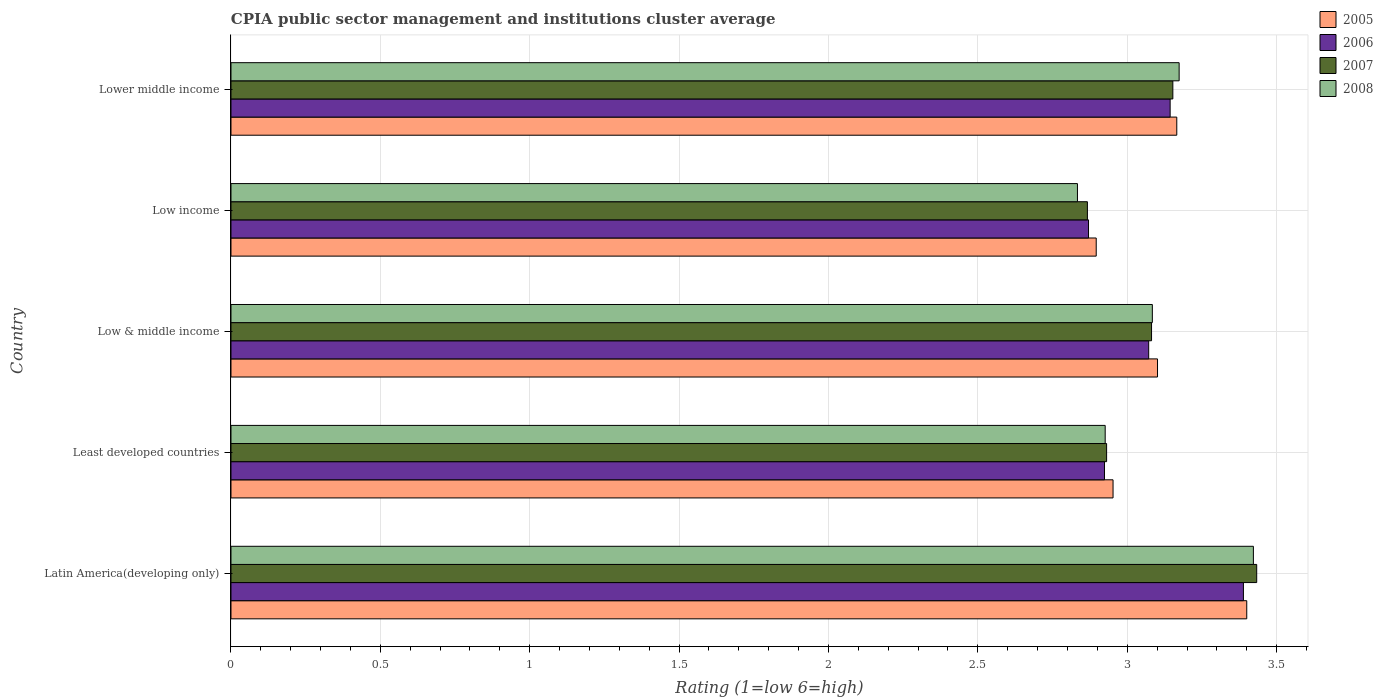How many different coloured bars are there?
Your answer should be very brief. 4. Are the number of bars per tick equal to the number of legend labels?
Provide a short and direct response. Yes. Are the number of bars on each tick of the Y-axis equal?
Offer a terse response. Yes. How many bars are there on the 5th tick from the top?
Keep it short and to the point. 4. What is the CPIA rating in 2007 in Latin America(developing only)?
Your response must be concise. 3.43. Across all countries, what is the maximum CPIA rating in 2008?
Your answer should be very brief. 3.42. Across all countries, what is the minimum CPIA rating in 2006?
Keep it short and to the point. 2.87. In which country was the CPIA rating in 2006 maximum?
Offer a terse response. Latin America(developing only). In which country was the CPIA rating in 2006 minimum?
Keep it short and to the point. Low income. What is the total CPIA rating in 2005 in the graph?
Your answer should be very brief. 15.52. What is the difference between the CPIA rating in 2007 in Least developed countries and that in Low income?
Make the answer very short. 0.06. What is the difference between the CPIA rating in 2005 in Latin America(developing only) and the CPIA rating in 2008 in Low & middle income?
Offer a terse response. 0.32. What is the average CPIA rating in 2006 per country?
Offer a very short reply. 3.08. What is the difference between the CPIA rating in 2007 and CPIA rating in 2008 in Latin America(developing only)?
Your answer should be compact. 0.01. What is the ratio of the CPIA rating in 2007 in Latin America(developing only) to that in Low & middle income?
Provide a short and direct response. 1.11. Is the CPIA rating in 2006 in Latin America(developing only) less than that in Low & middle income?
Your response must be concise. No. What is the difference between the highest and the second highest CPIA rating in 2007?
Your response must be concise. 0.28. What is the difference between the highest and the lowest CPIA rating in 2008?
Ensure brevity in your answer.  0.59. In how many countries, is the CPIA rating in 2008 greater than the average CPIA rating in 2008 taken over all countries?
Your answer should be very brief. 2. Is the sum of the CPIA rating in 2005 in Low & middle income and Lower middle income greater than the maximum CPIA rating in 2007 across all countries?
Your answer should be very brief. Yes. Is it the case that in every country, the sum of the CPIA rating in 2006 and CPIA rating in 2007 is greater than the sum of CPIA rating in 2005 and CPIA rating in 2008?
Ensure brevity in your answer.  No. Are all the bars in the graph horizontal?
Ensure brevity in your answer.  Yes. How many countries are there in the graph?
Make the answer very short. 5. What is the difference between two consecutive major ticks on the X-axis?
Give a very brief answer. 0.5. Are the values on the major ticks of X-axis written in scientific E-notation?
Ensure brevity in your answer.  No. Does the graph contain grids?
Your answer should be very brief. Yes. Where does the legend appear in the graph?
Offer a terse response. Top right. How are the legend labels stacked?
Offer a terse response. Vertical. What is the title of the graph?
Provide a short and direct response. CPIA public sector management and institutions cluster average. What is the label or title of the X-axis?
Provide a succinct answer. Rating (1=low 6=high). What is the label or title of the Y-axis?
Your answer should be very brief. Country. What is the Rating (1=low 6=high) of 2005 in Latin America(developing only)?
Give a very brief answer. 3.4. What is the Rating (1=low 6=high) of 2006 in Latin America(developing only)?
Your answer should be very brief. 3.39. What is the Rating (1=low 6=high) of 2007 in Latin America(developing only)?
Offer a terse response. 3.43. What is the Rating (1=low 6=high) of 2008 in Latin America(developing only)?
Give a very brief answer. 3.42. What is the Rating (1=low 6=high) in 2005 in Least developed countries?
Ensure brevity in your answer.  2.95. What is the Rating (1=low 6=high) in 2006 in Least developed countries?
Keep it short and to the point. 2.92. What is the Rating (1=low 6=high) of 2007 in Least developed countries?
Keep it short and to the point. 2.93. What is the Rating (1=low 6=high) of 2008 in Least developed countries?
Make the answer very short. 2.93. What is the Rating (1=low 6=high) of 2005 in Low & middle income?
Your response must be concise. 3.1. What is the Rating (1=low 6=high) in 2006 in Low & middle income?
Your response must be concise. 3.07. What is the Rating (1=low 6=high) of 2007 in Low & middle income?
Provide a succinct answer. 3.08. What is the Rating (1=low 6=high) of 2008 in Low & middle income?
Your response must be concise. 3.08. What is the Rating (1=low 6=high) of 2005 in Low income?
Make the answer very short. 2.9. What is the Rating (1=low 6=high) of 2006 in Low income?
Provide a succinct answer. 2.87. What is the Rating (1=low 6=high) of 2007 in Low income?
Keep it short and to the point. 2.87. What is the Rating (1=low 6=high) in 2008 in Low income?
Your answer should be very brief. 2.83. What is the Rating (1=low 6=high) in 2005 in Lower middle income?
Offer a very short reply. 3.17. What is the Rating (1=low 6=high) of 2006 in Lower middle income?
Offer a very short reply. 3.14. What is the Rating (1=low 6=high) in 2007 in Lower middle income?
Your response must be concise. 3.15. What is the Rating (1=low 6=high) in 2008 in Lower middle income?
Your answer should be compact. 3.17. Across all countries, what is the maximum Rating (1=low 6=high) of 2006?
Give a very brief answer. 3.39. Across all countries, what is the maximum Rating (1=low 6=high) of 2007?
Provide a succinct answer. 3.43. Across all countries, what is the maximum Rating (1=low 6=high) of 2008?
Offer a very short reply. 3.42. Across all countries, what is the minimum Rating (1=low 6=high) in 2005?
Your answer should be compact. 2.9. Across all countries, what is the minimum Rating (1=low 6=high) in 2006?
Your response must be concise. 2.87. Across all countries, what is the minimum Rating (1=low 6=high) of 2007?
Ensure brevity in your answer.  2.87. Across all countries, what is the minimum Rating (1=low 6=high) in 2008?
Ensure brevity in your answer.  2.83. What is the total Rating (1=low 6=high) in 2005 in the graph?
Make the answer very short. 15.52. What is the total Rating (1=low 6=high) of 2006 in the graph?
Offer a terse response. 15.4. What is the total Rating (1=low 6=high) of 2007 in the graph?
Provide a succinct answer. 15.46. What is the total Rating (1=low 6=high) of 2008 in the graph?
Ensure brevity in your answer.  15.44. What is the difference between the Rating (1=low 6=high) of 2005 in Latin America(developing only) and that in Least developed countries?
Make the answer very short. 0.45. What is the difference between the Rating (1=low 6=high) in 2006 in Latin America(developing only) and that in Least developed countries?
Your response must be concise. 0.47. What is the difference between the Rating (1=low 6=high) in 2007 in Latin America(developing only) and that in Least developed countries?
Provide a short and direct response. 0.5. What is the difference between the Rating (1=low 6=high) in 2008 in Latin America(developing only) and that in Least developed countries?
Offer a very short reply. 0.5. What is the difference between the Rating (1=low 6=high) of 2005 in Latin America(developing only) and that in Low & middle income?
Make the answer very short. 0.3. What is the difference between the Rating (1=low 6=high) of 2006 in Latin America(developing only) and that in Low & middle income?
Provide a short and direct response. 0.32. What is the difference between the Rating (1=low 6=high) of 2007 in Latin America(developing only) and that in Low & middle income?
Offer a terse response. 0.35. What is the difference between the Rating (1=low 6=high) in 2008 in Latin America(developing only) and that in Low & middle income?
Ensure brevity in your answer.  0.34. What is the difference between the Rating (1=low 6=high) in 2005 in Latin America(developing only) and that in Low income?
Your answer should be very brief. 0.5. What is the difference between the Rating (1=low 6=high) in 2006 in Latin America(developing only) and that in Low income?
Your response must be concise. 0.52. What is the difference between the Rating (1=low 6=high) of 2007 in Latin America(developing only) and that in Low income?
Your response must be concise. 0.57. What is the difference between the Rating (1=low 6=high) of 2008 in Latin America(developing only) and that in Low income?
Keep it short and to the point. 0.59. What is the difference between the Rating (1=low 6=high) of 2005 in Latin America(developing only) and that in Lower middle income?
Offer a terse response. 0.23. What is the difference between the Rating (1=low 6=high) of 2006 in Latin America(developing only) and that in Lower middle income?
Provide a succinct answer. 0.25. What is the difference between the Rating (1=low 6=high) in 2007 in Latin America(developing only) and that in Lower middle income?
Your answer should be very brief. 0.28. What is the difference between the Rating (1=low 6=high) in 2008 in Latin America(developing only) and that in Lower middle income?
Offer a terse response. 0.25. What is the difference between the Rating (1=low 6=high) in 2005 in Least developed countries and that in Low & middle income?
Keep it short and to the point. -0.15. What is the difference between the Rating (1=low 6=high) in 2006 in Least developed countries and that in Low & middle income?
Your answer should be very brief. -0.15. What is the difference between the Rating (1=low 6=high) in 2007 in Least developed countries and that in Low & middle income?
Your answer should be compact. -0.15. What is the difference between the Rating (1=low 6=high) of 2008 in Least developed countries and that in Low & middle income?
Keep it short and to the point. -0.16. What is the difference between the Rating (1=low 6=high) in 2005 in Least developed countries and that in Low income?
Ensure brevity in your answer.  0.06. What is the difference between the Rating (1=low 6=high) in 2006 in Least developed countries and that in Low income?
Ensure brevity in your answer.  0.05. What is the difference between the Rating (1=low 6=high) of 2007 in Least developed countries and that in Low income?
Give a very brief answer. 0.06. What is the difference between the Rating (1=low 6=high) of 2008 in Least developed countries and that in Low income?
Offer a very short reply. 0.09. What is the difference between the Rating (1=low 6=high) in 2005 in Least developed countries and that in Lower middle income?
Offer a very short reply. -0.21. What is the difference between the Rating (1=low 6=high) in 2006 in Least developed countries and that in Lower middle income?
Make the answer very short. -0.22. What is the difference between the Rating (1=low 6=high) of 2007 in Least developed countries and that in Lower middle income?
Your answer should be compact. -0.22. What is the difference between the Rating (1=low 6=high) of 2008 in Least developed countries and that in Lower middle income?
Provide a short and direct response. -0.25. What is the difference between the Rating (1=low 6=high) in 2005 in Low & middle income and that in Low income?
Your response must be concise. 0.21. What is the difference between the Rating (1=low 6=high) of 2006 in Low & middle income and that in Low income?
Your answer should be very brief. 0.2. What is the difference between the Rating (1=low 6=high) in 2007 in Low & middle income and that in Low income?
Keep it short and to the point. 0.21. What is the difference between the Rating (1=low 6=high) of 2008 in Low & middle income and that in Low income?
Your answer should be very brief. 0.25. What is the difference between the Rating (1=low 6=high) of 2005 in Low & middle income and that in Lower middle income?
Make the answer very short. -0.06. What is the difference between the Rating (1=low 6=high) of 2006 in Low & middle income and that in Lower middle income?
Keep it short and to the point. -0.07. What is the difference between the Rating (1=low 6=high) in 2007 in Low & middle income and that in Lower middle income?
Make the answer very short. -0.07. What is the difference between the Rating (1=low 6=high) of 2008 in Low & middle income and that in Lower middle income?
Give a very brief answer. -0.09. What is the difference between the Rating (1=low 6=high) of 2005 in Low income and that in Lower middle income?
Offer a very short reply. -0.27. What is the difference between the Rating (1=low 6=high) in 2006 in Low income and that in Lower middle income?
Offer a very short reply. -0.27. What is the difference between the Rating (1=low 6=high) of 2007 in Low income and that in Lower middle income?
Your response must be concise. -0.29. What is the difference between the Rating (1=low 6=high) of 2008 in Low income and that in Lower middle income?
Your response must be concise. -0.34. What is the difference between the Rating (1=low 6=high) of 2005 in Latin America(developing only) and the Rating (1=low 6=high) of 2006 in Least developed countries?
Offer a terse response. 0.48. What is the difference between the Rating (1=low 6=high) of 2005 in Latin America(developing only) and the Rating (1=low 6=high) of 2007 in Least developed countries?
Give a very brief answer. 0.47. What is the difference between the Rating (1=low 6=high) in 2005 in Latin America(developing only) and the Rating (1=low 6=high) in 2008 in Least developed countries?
Give a very brief answer. 0.47. What is the difference between the Rating (1=low 6=high) of 2006 in Latin America(developing only) and the Rating (1=low 6=high) of 2007 in Least developed countries?
Your answer should be very brief. 0.46. What is the difference between the Rating (1=low 6=high) of 2006 in Latin America(developing only) and the Rating (1=low 6=high) of 2008 in Least developed countries?
Make the answer very short. 0.46. What is the difference between the Rating (1=low 6=high) of 2007 in Latin America(developing only) and the Rating (1=low 6=high) of 2008 in Least developed countries?
Your answer should be compact. 0.51. What is the difference between the Rating (1=low 6=high) in 2005 in Latin America(developing only) and the Rating (1=low 6=high) in 2006 in Low & middle income?
Provide a succinct answer. 0.33. What is the difference between the Rating (1=low 6=high) of 2005 in Latin America(developing only) and the Rating (1=low 6=high) of 2007 in Low & middle income?
Your response must be concise. 0.32. What is the difference between the Rating (1=low 6=high) of 2005 in Latin America(developing only) and the Rating (1=low 6=high) of 2008 in Low & middle income?
Provide a short and direct response. 0.32. What is the difference between the Rating (1=low 6=high) of 2006 in Latin America(developing only) and the Rating (1=low 6=high) of 2007 in Low & middle income?
Offer a terse response. 0.31. What is the difference between the Rating (1=low 6=high) in 2006 in Latin America(developing only) and the Rating (1=low 6=high) in 2008 in Low & middle income?
Provide a short and direct response. 0.3. What is the difference between the Rating (1=low 6=high) in 2007 in Latin America(developing only) and the Rating (1=low 6=high) in 2008 in Low & middle income?
Your response must be concise. 0.35. What is the difference between the Rating (1=low 6=high) of 2005 in Latin America(developing only) and the Rating (1=low 6=high) of 2006 in Low income?
Offer a very short reply. 0.53. What is the difference between the Rating (1=low 6=high) of 2005 in Latin America(developing only) and the Rating (1=low 6=high) of 2007 in Low income?
Make the answer very short. 0.53. What is the difference between the Rating (1=low 6=high) of 2005 in Latin America(developing only) and the Rating (1=low 6=high) of 2008 in Low income?
Give a very brief answer. 0.57. What is the difference between the Rating (1=low 6=high) of 2006 in Latin America(developing only) and the Rating (1=low 6=high) of 2007 in Low income?
Provide a succinct answer. 0.52. What is the difference between the Rating (1=low 6=high) of 2006 in Latin America(developing only) and the Rating (1=low 6=high) of 2008 in Low income?
Give a very brief answer. 0.56. What is the difference between the Rating (1=low 6=high) of 2005 in Latin America(developing only) and the Rating (1=low 6=high) of 2006 in Lower middle income?
Your answer should be compact. 0.26. What is the difference between the Rating (1=low 6=high) of 2005 in Latin America(developing only) and the Rating (1=low 6=high) of 2007 in Lower middle income?
Give a very brief answer. 0.25. What is the difference between the Rating (1=low 6=high) of 2005 in Latin America(developing only) and the Rating (1=low 6=high) of 2008 in Lower middle income?
Keep it short and to the point. 0.23. What is the difference between the Rating (1=low 6=high) of 2006 in Latin America(developing only) and the Rating (1=low 6=high) of 2007 in Lower middle income?
Provide a short and direct response. 0.24. What is the difference between the Rating (1=low 6=high) in 2006 in Latin America(developing only) and the Rating (1=low 6=high) in 2008 in Lower middle income?
Offer a very short reply. 0.22. What is the difference between the Rating (1=low 6=high) of 2007 in Latin America(developing only) and the Rating (1=low 6=high) of 2008 in Lower middle income?
Your response must be concise. 0.26. What is the difference between the Rating (1=low 6=high) in 2005 in Least developed countries and the Rating (1=low 6=high) in 2006 in Low & middle income?
Make the answer very short. -0.12. What is the difference between the Rating (1=low 6=high) in 2005 in Least developed countries and the Rating (1=low 6=high) in 2007 in Low & middle income?
Make the answer very short. -0.13. What is the difference between the Rating (1=low 6=high) of 2005 in Least developed countries and the Rating (1=low 6=high) of 2008 in Low & middle income?
Provide a short and direct response. -0.13. What is the difference between the Rating (1=low 6=high) in 2006 in Least developed countries and the Rating (1=low 6=high) in 2007 in Low & middle income?
Provide a succinct answer. -0.16. What is the difference between the Rating (1=low 6=high) in 2006 in Least developed countries and the Rating (1=low 6=high) in 2008 in Low & middle income?
Offer a terse response. -0.16. What is the difference between the Rating (1=low 6=high) in 2007 in Least developed countries and the Rating (1=low 6=high) in 2008 in Low & middle income?
Offer a very short reply. -0.15. What is the difference between the Rating (1=low 6=high) of 2005 in Least developed countries and the Rating (1=low 6=high) of 2006 in Low income?
Provide a short and direct response. 0.08. What is the difference between the Rating (1=low 6=high) in 2005 in Least developed countries and the Rating (1=low 6=high) in 2007 in Low income?
Keep it short and to the point. 0.09. What is the difference between the Rating (1=low 6=high) in 2005 in Least developed countries and the Rating (1=low 6=high) in 2008 in Low income?
Offer a terse response. 0.12. What is the difference between the Rating (1=low 6=high) in 2006 in Least developed countries and the Rating (1=low 6=high) in 2007 in Low income?
Provide a short and direct response. 0.06. What is the difference between the Rating (1=low 6=high) of 2006 in Least developed countries and the Rating (1=low 6=high) of 2008 in Low income?
Your response must be concise. 0.09. What is the difference between the Rating (1=low 6=high) of 2007 in Least developed countries and the Rating (1=low 6=high) of 2008 in Low income?
Your response must be concise. 0.1. What is the difference between the Rating (1=low 6=high) of 2005 in Least developed countries and the Rating (1=low 6=high) of 2006 in Lower middle income?
Offer a terse response. -0.19. What is the difference between the Rating (1=low 6=high) in 2005 in Least developed countries and the Rating (1=low 6=high) in 2007 in Lower middle income?
Give a very brief answer. -0.2. What is the difference between the Rating (1=low 6=high) in 2005 in Least developed countries and the Rating (1=low 6=high) in 2008 in Lower middle income?
Your response must be concise. -0.22. What is the difference between the Rating (1=low 6=high) of 2006 in Least developed countries and the Rating (1=low 6=high) of 2007 in Lower middle income?
Your answer should be compact. -0.23. What is the difference between the Rating (1=low 6=high) in 2006 in Least developed countries and the Rating (1=low 6=high) in 2008 in Lower middle income?
Make the answer very short. -0.25. What is the difference between the Rating (1=low 6=high) of 2007 in Least developed countries and the Rating (1=low 6=high) of 2008 in Lower middle income?
Offer a terse response. -0.24. What is the difference between the Rating (1=low 6=high) in 2005 in Low & middle income and the Rating (1=low 6=high) in 2006 in Low income?
Provide a succinct answer. 0.23. What is the difference between the Rating (1=low 6=high) in 2005 in Low & middle income and the Rating (1=low 6=high) in 2007 in Low income?
Make the answer very short. 0.23. What is the difference between the Rating (1=low 6=high) of 2005 in Low & middle income and the Rating (1=low 6=high) of 2008 in Low income?
Your response must be concise. 0.27. What is the difference between the Rating (1=low 6=high) in 2006 in Low & middle income and the Rating (1=low 6=high) in 2007 in Low income?
Keep it short and to the point. 0.21. What is the difference between the Rating (1=low 6=high) of 2006 in Low & middle income and the Rating (1=low 6=high) of 2008 in Low income?
Offer a very short reply. 0.24. What is the difference between the Rating (1=low 6=high) of 2007 in Low & middle income and the Rating (1=low 6=high) of 2008 in Low income?
Ensure brevity in your answer.  0.25. What is the difference between the Rating (1=low 6=high) in 2005 in Low & middle income and the Rating (1=low 6=high) in 2006 in Lower middle income?
Your answer should be very brief. -0.04. What is the difference between the Rating (1=low 6=high) in 2005 in Low & middle income and the Rating (1=low 6=high) in 2007 in Lower middle income?
Your answer should be compact. -0.05. What is the difference between the Rating (1=low 6=high) in 2005 in Low & middle income and the Rating (1=low 6=high) in 2008 in Lower middle income?
Give a very brief answer. -0.07. What is the difference between the Rating (1=low 6=high) of 2006 in Low & middle income and the Rating (1=low 6=high) of 2007 in Lower middle income?
Your response must be concise. -0.08. What is the difference between the Rating (1=low 6=high) of 2006 in Low & middle income and the Rating (1=low 6=high) of 2008 in Lower middle income?
Provide a succinct answer. -0.1. What is the difference between the Rating (1=low 6=high) in 2007 in Low & middle income and the Rating (1=low 6=high) in 2008 in Lower middle income?
Offer a terse response. -0.09. What is the difference between the Rating (1=low 6=high) in 2005 in Low income and the Rating (1=low 6=high) in 2006 in Lower middle income?
Give a very brief answer. -0.25. What is the difference between the Rating (1=low 6=high) in 2005 in Low income and the Rating (1=low 6=high) in 2007 in Lower middle income?
Your answer should be very brief. -0.26. What is the difference between the Rating (1=low 6=high) in 2005 in Low income and the Rating (1=low 6=high) in 2008 in Lower middle income?
Offer a terse response. -0.28. What is the difference between the Rating (1=low 6=high) in 2006 in Low income and the Rating (1=low 6=high) in 2007 in Lower middle income?
Your answer should be compact. -0.28. What is the difference between the Rating (1=low 6=high) of 2006 in Low income and the Rating (1=low 6=high) of 2008 in Lower middle income?
Ensure brevity in your answer.  -0.3. What is the difference between the Rating (1=low 6=high) of 2007 in Low income and the Rating (1=low 6=high) of 2008 in Lower middle income?
Keep it short and to the point. -0.31. What is the average Rating (1=low 6=high) of 2005 per country?
Keep it short and to the point. 3.1. What is the average Rating (1=low 6=high) in 2006 per country?
Provide a short and direct response. 3.08. What is the average Rating (1=low 6=high) of 2007 per country?
Provide a short and direct response. 3.09. What is the average Rating (1=low 6=high) in 2008 per country?
Your answer should be very brief. 3.09. What is the difference between the Rating (1=low 6=high) of 2005 and Rating (1=low 6=high) of 2006 in Latin America(developing only)?
Your response must be concise. 0.01. What is the difference between the Rating (1=low 6=high) of 2005 and Rating (1=low 6=high) of 2007 in Latin America(developing only)?
Provide a short and direct response. -0.03. What is the difference between the Rating (1=low 6=high) in 2005 and Rating (1=low 6=high) in 2008 in Latin America(developing only)?
Your answer should be very brief. -0.02. What is the difference between the Rating (1=low 6=high) in 2006 and Rating (1=low 6=high) in 2007 in Latin America(developing only)?
Ensure brevity in your answer.  -0.04. What is the difference between the Rating (1=low 6=high) in 2006 and Rating (1=low 6=high) in 2008 in Latin America(developing only)?
Keep it short and to the point. -0.03. What is the difference between the Rating (1=low 6=high) of 2007 and Rating (1=low 6=high) of 2008 in Latin America(developing only)?
Provide a short and direct response. 0.01. What is the difference between the Rating (1=low 6=high) of 2005 and Rating (1=low 6=high) of 2006 in Least developed countries?
Make the answer very short. 0.03. What is the difference between the Rating (1=low 6=high) of 2005 and Rating (1=low 6=high) of 2007 in Least developed countries?
Offer a very short reply. 0.02. What is the difference between the Rating (1=low 6=high) of 2005 and Rating (1=low 6=high) of 2008 in Least developed countries?
Your answer should be compact. 0.03. What is the difference between the Rating (1=low 6=high) of 2006 and Rating (1=low 6=high) of 2007 in Least developed countries?
Give a very brief answer. -0.01. What is the difference between the Rating (1=low 6=high) in 2006 and Rating (1=low 6=high) in 2008 in Least developed countries?
Your response must be concise. -0. What is the difference between the Rating (1=low 6=high) of 2007 and Rating (1=low 6=high) of 2008 in Least developed countries?
Your answer should be very brief. 0. What is the difference between the Rating (1=low 6=high) in 2005 and Rating (1=low 6=high) in 2006 in Low & middle income?
Your answer should be very brief. 0.03. What is the difference between the Rating (1=low 6=high) of 2005 and Rating (1=low 6=high) of 2008 in Low & middle income?
Keep it short and to the point. 0.02. What is the difference between the Rating (1=low 6=high) in 2006 and Rating (1=low 6=high) in 2007 in Low & middle income?
Keep it short and to the point. -0.01. What is the difference between the Rating (1=low 6=high) in 2006 and Rating (1=low 6=high) in 2008 in Low & middle income?
Give a very brief answer. -0.01. What is the difference between the Rating (1=low 6=high) of 2007 and Rating (1=low 6=high) of 2008 in Low & middle income?
Ensure brevity in your answer.  -0. What is the difference between the Rating (1=low 6=high) in 2005 and Rating (1=low 6=high) in 2006 in Low income?
Provide a succinct answer. 0.03. What is the difference between the Rating (1=low 6=high) in 2005 and Rating (1=low 6=high) in 2007 in Low income?
Your response must be concise. 0.03. What is the difference between the Rating (1=low 6=high) in 2005 and Rating (1=low 6=high) in 2008 in Low income?
Provide a short and direct response. 0.06. What is the difference between the Rating (1=low 6=high) in 2006 and Rating (1=low 6=high) in 2007 in Low income?
Your answer should be very brief. 0. What is the difference between the Rating (1=low 6=high) of 2006 and Rating (1=low 6=high) of 2008 in Low income?
Keep it short and to the point. 0.04. What is the difference between the Rating (1=low 6=high) of 2005 and Rating (1=low 6=high) of 2006 in Lower middle income?
Offer a very short reply. 0.02. What is the difference between the Rating (1=low 6=high) of 2005 and Rating (1=low 6=high) of 2007 in Lower middle income?
Keep it short and to the point. 0.01. What is the difference between the Rating (1=low 6=high) of 2005 and Rating (1=low 6=high) of 2008 in Lower middle income?
Your answer should be compact. -0.01. What is the difference between the Rating (1=low 6=high) of 2006 and Rating (1=low 6=high) of 2007 in Lower middle income?
Provide a short and direct response. -0.01. What is the difference between the Rating (1=low 6=high) of 2006 and Rating (1=low 6=high) of 2008 in Lower middle income?
Offer a very short reply. -0.03. What is the difference between the Rating (1=low 6=high) of 2007 and Rating (1=low 6=high) of 2008 in Lower middle income?
Provide a short and direct response. -0.02. What is the ratio of the Rating (1=low 6=high) of 2005 in Latin America(developing only) to that in Least developed countries?
Offer a very short reply. 1.15. What is the ratio of the Rating (1=low 6=high) of 2006 in Latin America(developing only) to that in Least developed countries?
Offer a terse response. 1.16. What is the ratio of the Rating (1=low 6=high) in 2007 in Latin America(developing only) to that in Least developed countries?
Your answer should be compact. 1.17. What is the ratio of the Rating (1=low 6=high) of 2008 in Latin America(developing only) to that in Least developed countries?
Make the answer very short. 1.17. What is the ratio of the Rating (1=low 6=high) of 2005 in Latin America(developing only) to that in Low & middle income?
Provide a short and direct response. 1.1. What is the ratio of the Rating (1=low 6=high) in 2006 in Latin America(developing only) to that in Low & middle income?
Provide a short and direct response. 1.1. What is the ratio of the Rating (1=low 6=high) of 2007 in Latin America(developing only) to that in Low & middle income?
Offer a very short reply. 1.11. What is the ratio of the Rating (1=low 6=high) of 2008 in Latin America(developing only) to that in Low & middle income?
Make the answer very short. 1.11. What is the ratio of the Rating (1=low 6=high) in 2005 in Latin America(developing only) to that in Low income?
Provide a short and direct response. 1.17. What is the ratio of the Rating (1=low 6=high) in 2006 in Latin America(developing only) to that in Low income?
Offer a terse response. 1.18. What is the ratio of the Rating (1=low 6=high) in 2007 in Latin America(developing only) to that in Low income?
Offer a very short reply. 1.2. What is the ratio of the Rating (1=low 6=high) of 2008 in Latin America(developing only) to that in Low income?
Offer a very short reply. 1.21. What is the ratio of the Rating (1=low 6=high) of 2005 in Latin America(developing only) to that in Lower middle income?
Provide a short and direct response. 1.07. What is the ratio of the Rating (1=low 6=high) of 2006 in Latin America(developing only) to that in Lower middle income?
Offer a terse response. 1.08. What is the ratio of the Rating (1=low 6=high) of 2007 in Latin America(developing only) to that in Lower middle income?
Keep it short and to the point. 1.09. What is the ratio of the Rating (1=low 6=high) in 2008 in Latin America(developing only) to that in Lower middle income?
Your answer should be compact. 1.08. What is the ratio of the Rating (1=low 6=high) of 2005 in Least developed countries to that in Low & middle income?
Make the answer very short. 0.95. What is the ratio of the Rating (1=low 6=high) in 2006 in Least developed countries to that in Low & middle income?
Your answer should be compact. 0.95. What is the ratio of the Rating (1=low 6=high) of 2007 in Least developed countries to that in Low & middle income?
Your answer should be very brief. 0.95. What is the ratio of the Rating (1=low 6=high) of 2008 in Least developed countries to that in Low & middle income?
Provide a short and direct response. 0.95. What is the ratio of the Rating (1=low 6=high) in 2005 in Least developed countries to that in Low income?
Give a very brief answer. 1.02. What is the ratio of the Rating (1=low 6=high) in 2006 in Least developed countries to that in Low income?
Make the answer very short. 1.02. What is the ratio of the Rating (1=low 6=high) in 2007 in Least developed countries to that in Low income?
Give a very brief answer. 1.02. What is the ratio of the Rating (1=low 6=high) in 2008 in Least developed countries to that in Low income?
Make the answer very short. 1.03. What is the ratio of the Rating (1=low 6=high) of 2005 in Least developed countries to that in Lower middle income?
Make the answer very short. 0.93. What is the ratio of the Rating (1=low 6=high) in 2006 in Least developed countries to that in Lower middle income?
Your response must be concise. 0.93. What is the ratio of the Rating (1=low 6=high) in 2007 in Least developed countries to that in Lower middle income?
Your answer should be compact. 0.93. What is the ratio of the Rating (1=low 6=high) of 2008 in Least developed countries to that in Lower middle income?
Make the answer very short. 0.92. What is the ratio of the Rating (1=low 6=high) of 2005 in Low & middle income to that in Low income?
Provide a succinct answer. 1.07. What is the ratio of the Rating (1=low 6=high) in 2006 in Low & middle income to that in Low income?
Your response must be concise. 1.07. What is the ratio of the Rating (1=low 6=high) of 2007 in Low & middle income to that in Low income?
Your response must be concise. 1.07. What is the ratio of the Rating (1=low 6=high) of 2008 in Low & middle income to that in Low income?
Provide a succinct answer. 1.09. What is the ratio of the Rating (1=low 6=high) in 2005 in Low & middle income to that in Lower middle income?
Your response must be concise. 0.98. What is the ratio of the Rating (1=low 6=high) of 2006 in Low & middle income to that in Lower middle income?
Your answer should be very brief. 0.98. What is the ratio of the Rating (1=low 6=high) of 2007 in Low & middle income to that in Lower middle income?
Make the answer very short. 0.98. What is the ratio of the Rating (1=low 6=high) of 2008 in Low & middle income to that in Lower middle income?
Your answer should be compact. 0.97. What is the ratio of the Rating (1=low 6=high) of 2005 in Low income to that in Lower middle income?
Offer a terse response. 0.91. What is the ratio of the Rating (1=low 6=high) of 2006 in Low income to that in Lower middle income?
Make the answer very short. 0.91. What is the ratio of the Rating (1=low 6=high) of 2007 in Low income to that in Lower middle income?
Provide a succinct answer. 0.91. What is the ratio of the Rating (1=low 6=high) in 2008 in Low income to that in Lower middle income?
Offer a terse response. 0.89. What is the difference between the highest and the second highest Rating (1=low 6=high) in 2005?
Offer a terse response. 0.23. What is the difference between the highest and the second highest Rating (1=low 6=high) in 2006?
Make the answer very short. 0.25. What is the difference between the highest and the second highest Rating (1=low 6=high) of 2007?
Give a very brief answer. 0.28. What is the difference between the highest and the second highest Rating (1=low 6=high) of 2008?
Offer a very short reply. 0.25. What is the difference between the highest and the lowest Rating (1=low 6=high) in 2005?
Make the answer very short. 0.5. What is the difference between the highest and the lowest Rating (1=low 6=high) of 2006?
Make the answer very short. 0.52. What is the difference between the highest and the lowest Rating (1=low 6=high) of 2007?
Your answer should be very brief. 0.57. What is the difference between the highest and the lowest Rating (1=low 6=high) of 2008?
Give a very brief answer. 0.59. 